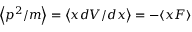<formula> <loc_0><loc_0><loc_500><loc_500>\left \langle p ^ { 2 } / m \right \rangle = \left \langle x d V / d x \right \rangle = - \langle x F \rangle</formula> 